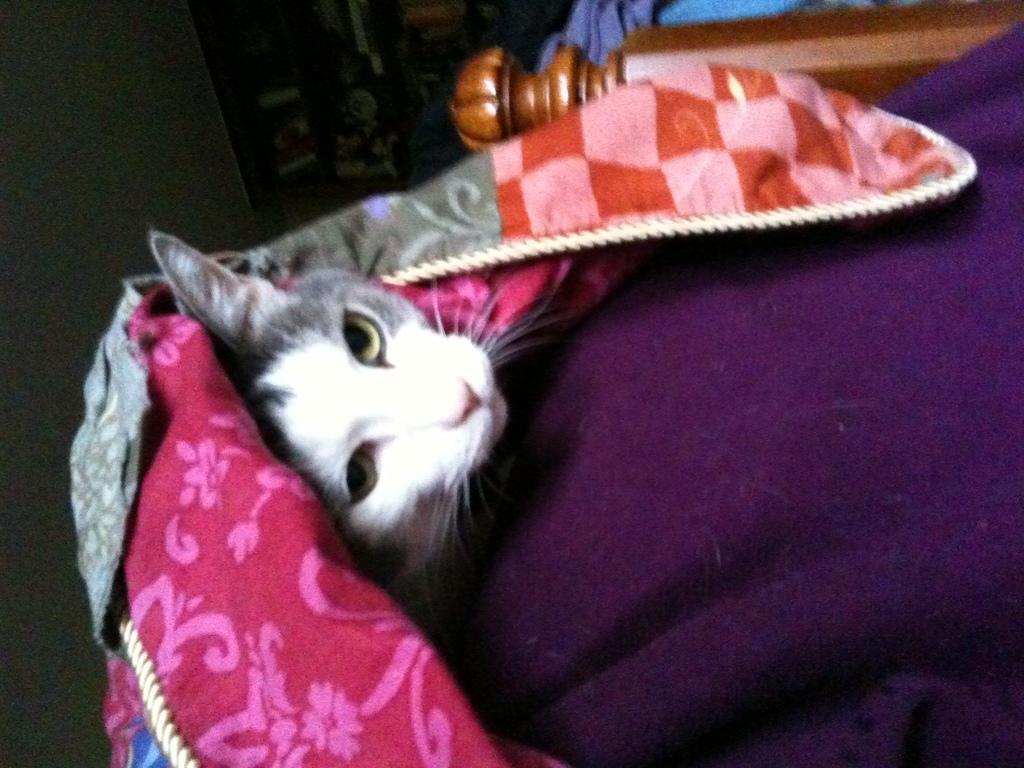What type of animal is in the image? There is a cat in the image. What type of material is present in the image? There are blankets in the image. What type of structure is in the image? There is a wooden pillar in the image. What is visible at the top of the image? There are objects visible at the top of the image. What type of insect can be seen crawling on the cat in the image? There is no insect visible on the cat in the image. What type of fruit is the cat holding in the image? The cat is not holding any fruit in the image. 